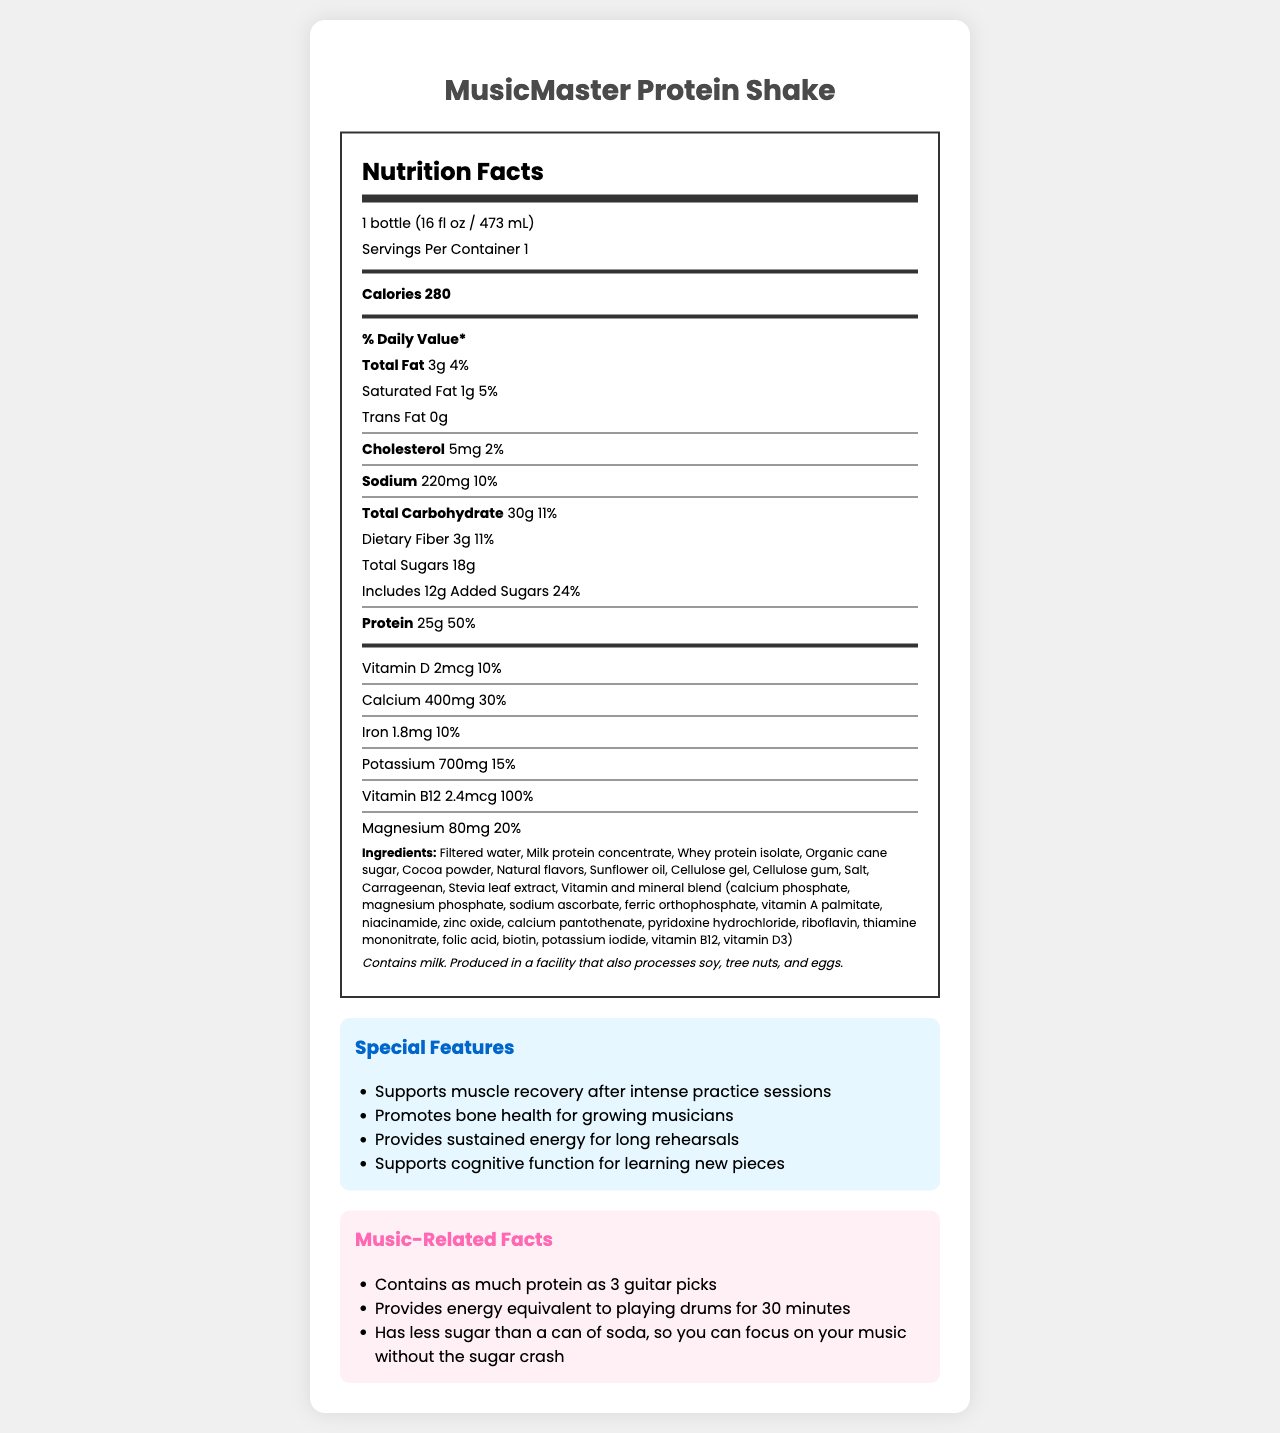what is the serving size of the MusicMaster Protein Shake? The serving size is explicitly stated at the beginning of the Nutrition Facts section.
Answer: 1 bottle (16 fl oz / 473 mL) How many calories are in one serving of the protein shake? The calorie content per serving is specified as 280 calories in the Nutrition Facts section.
Answer: 280 What percentage of the daily value is the protein content? The protein section states 25g of protein, which is 50% of the daily value.
Answer: 50% Which ingredient is listed first in the ingredients list? The ingredients are listed in order of quantity, with filtered water being the first one mentioned.
Answer: Filtered water Does the MusicMaster Protein Shake contain any trans fat? The Nutrition Facts section shows that the amount of trans fat is 0g.
Answer: No How much sodium does one serving contain? The sodium content per serving is listed as 220mg in the Nutrition Facts section.
Answer: 220mg What are the special features of the MusicMaster Protein Shake? The special features are listed in a dedicated section towards the end of the document.
Answer: Supports muscle recovery after intense practice sessions, Promotes bone health for growing musicians, Provides sustained energy for long rehearsals, Supports cognitive function for learning new pieces What is the total amount of sugars (including added sugars) in one serving? A. 18g B. 12g C. 30g D. 40g The Nutrition Facts section lists total sugars as 18g, which includes 12g of added sugars.
Answer: A What is the daily value percentage of calcium provided by the protein shake? A. 10% B. 20% C. 30% D. 50% The calcium section states that the shake provides 30% of the daily value.
Answer: C Does this product contain any allergens? The allergen information specifies that the product contains milk and is produced in a facility that processes soy, tree nuts, and eggs.
Answer: Yes Summarize the main components of the MusicMaster Protein Shake. The summary encapsulates the key nutritional values, special features, and the intended audience of the product based on the visual information.
Answer: The MusicMaster Protein Shake is a nutrition-rich drink containing 280 calories, 3g of total fat, 25g of protein, and various vitamins and minerals. It supports muscle recovery, promotes bone health, provides sustained energy, and supports cognitive function. The shake is designed especially for young musicians and is free of trans fat but contains milk, with added sugars totaling 12g. How much vitamin B12 does the shake provide? The Nutrition Facts section shows that the shake provides 2.4mcg of vitamin B12, which is 100% of the daily value.
Answer: 2.4mcg How long of a drumming session's energy does one serving provide? In the Music-Related Facts section, it mentions that the shake provides energy equivalent to playing drums for 30 minutes.
Answer: 30 minutes What flavor does the shake have? The document does not specify the flavor of the shake, so this information cannot be determined.
Answer: Not enough information 